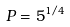<formula> <loc_0><loc_0><loc_500><loc_500>P = 5 ^ { 1 / 4 }</formula> 